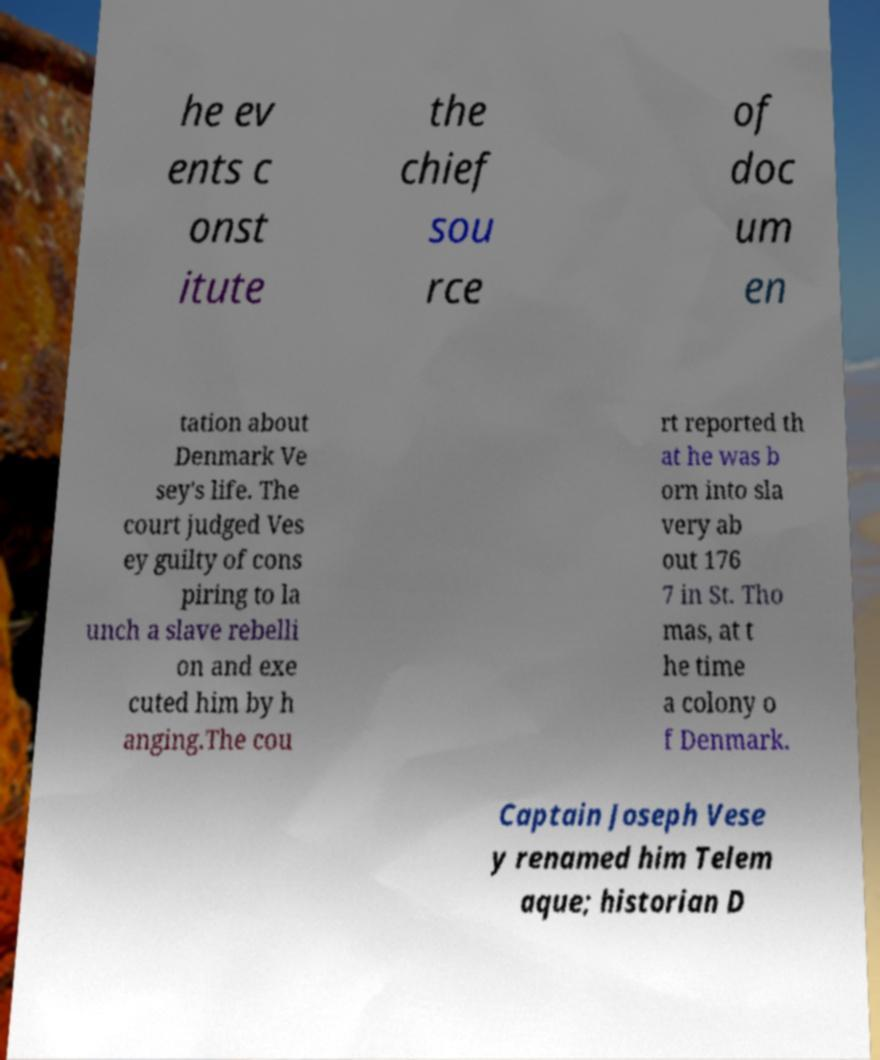Could you extract and type out the text from this image? he ev ents c onst itute the chief sou rce of doc um en tation about Denmark Ve sey's life. The court judged Ves ey guilty of cons piring to la unch a slave rebelli on and exe cuted him by h anging.The cou rt reported th at he was b orn into sla very ab out 176 7 in St. Tho mas, at t he time a colony o f Denmark. Captain Joseph Vese y renamed him Telem aque; historian D 